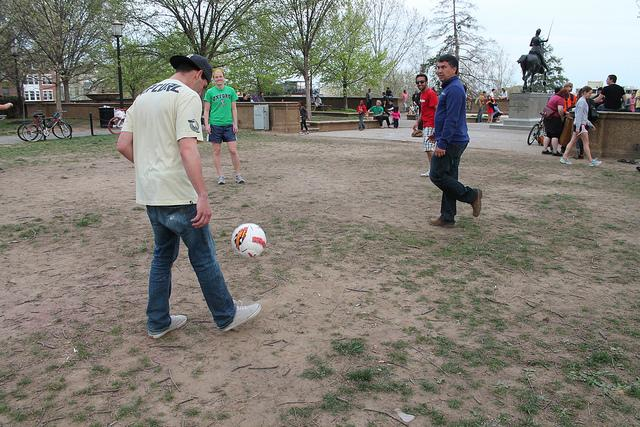What sport other that the ball's proper sport does the ball look closest to belonging to? volleyball 